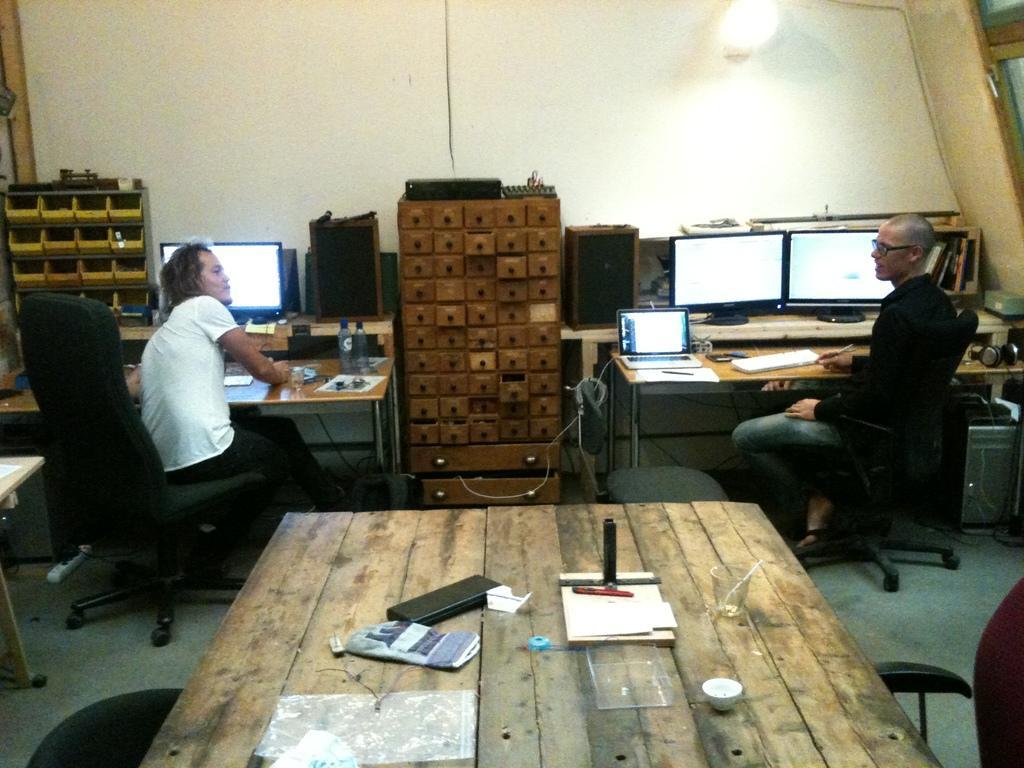How would you summarize this image in a sentence or two? It is the closed picture where two people are present or at the right corner of the picture one person is sitting in the chair wearing a black shirt and jeans and in the left corner of the picture one person is wearing a white t-shirt and in front of him there is a one system and table, water bottles and between both people there is one wooden rack and speakers and between the person and in front of the person there are three monitors and behind the monitors there is a big wall and in the centre of the picture there is one table and some things on it. 